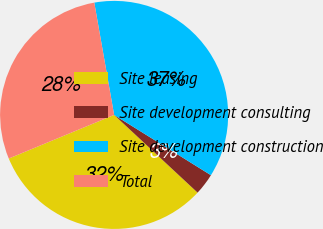Convert chart. <chart><loc_0><loc_0><loc_500><loc_500><pie_chart><fcel>Site leasing<fcel>Site development consulting<fcel>Site development construction<fcel>Total<nl><fcel>31.82%<fcel>3.07%<fcel>36.65%<fcel>28.46%<nl></chart> 